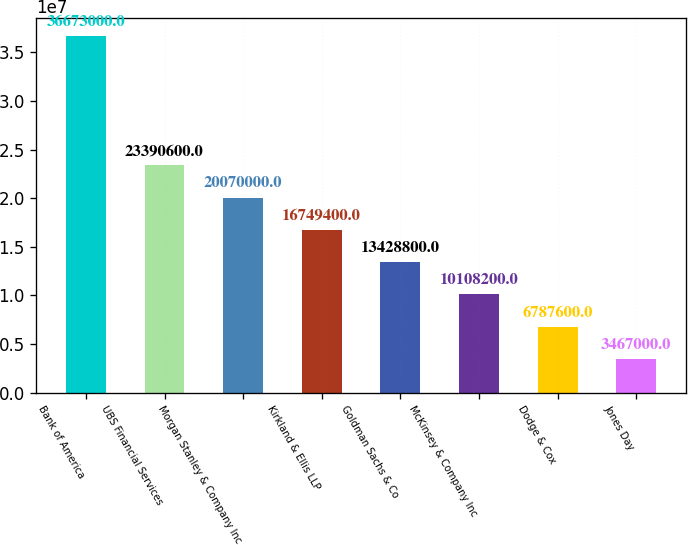<chart> <loc_0><loc_0><loc_500><loc_500><bar_chart><fcel>Bank of America<fcel>UBS Financial Services<fcel>Morgan Stanley & Company Inc<fcel>Kirkland & Ellis LLP<fcel>Goldman Sachs & Co<fcel>McKinsey & Company Inc<fcel>Dodge & Cox<fcel>Jones Day<nl><fcel>3.6673e+07<fcel>2.33906e+07<fcel>2.007e+07<fcel>1.67494e+07<fcel>1.34288e+07<fcel>1.01082e+07<fcel>6.7876e+06<fcel>3.467e+06<nl></chart> 